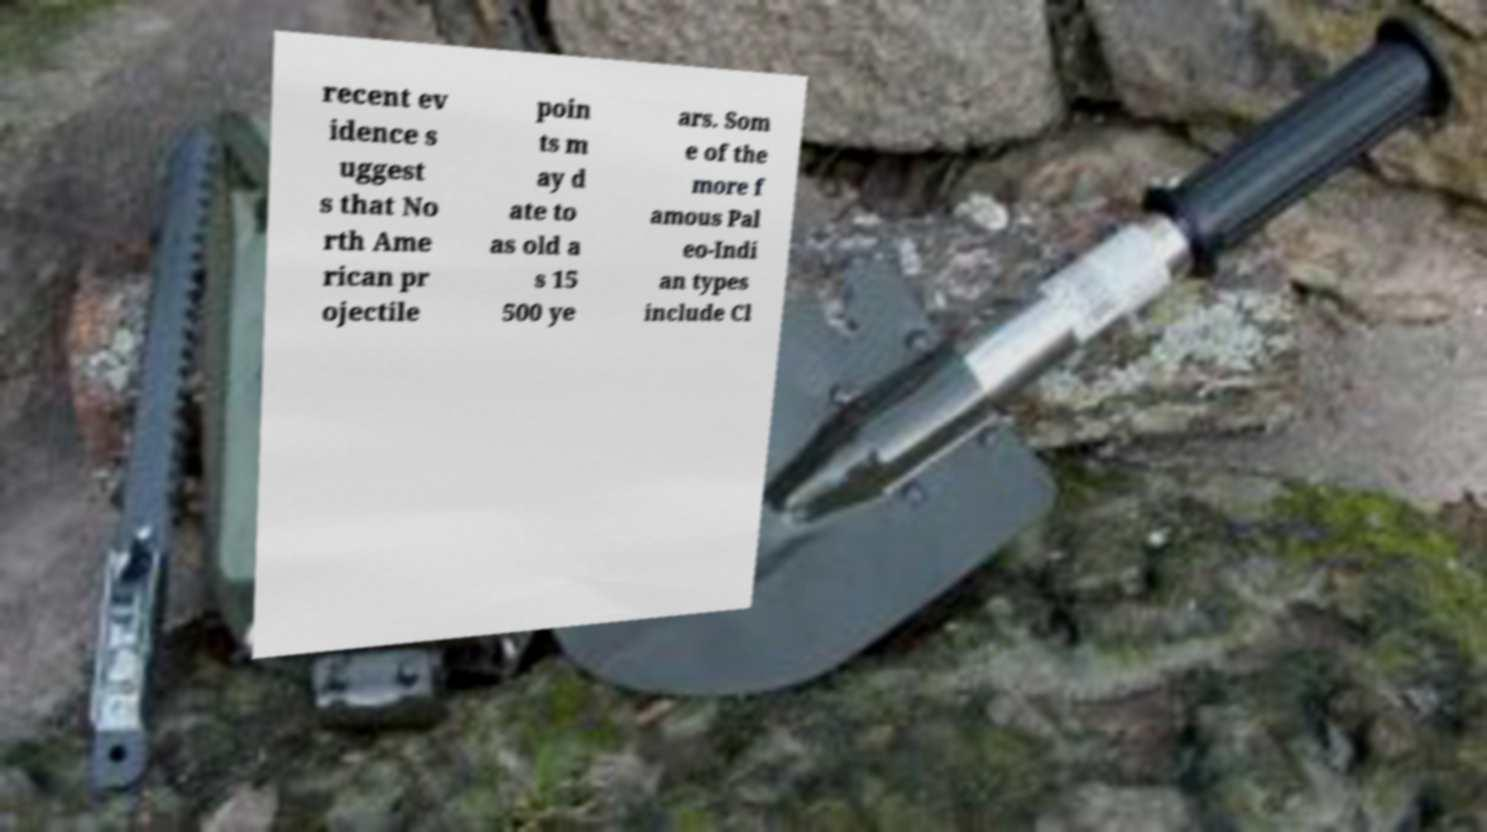I need the written content from this picture converted into text. Can you do that? recent ev idence s uggest s that No rth Ame rican pr ojectile poin ts m ay d ate to as old a s 15 500 ye ars. Som e of the more f amous Pal eo-Indi an types include Cl 